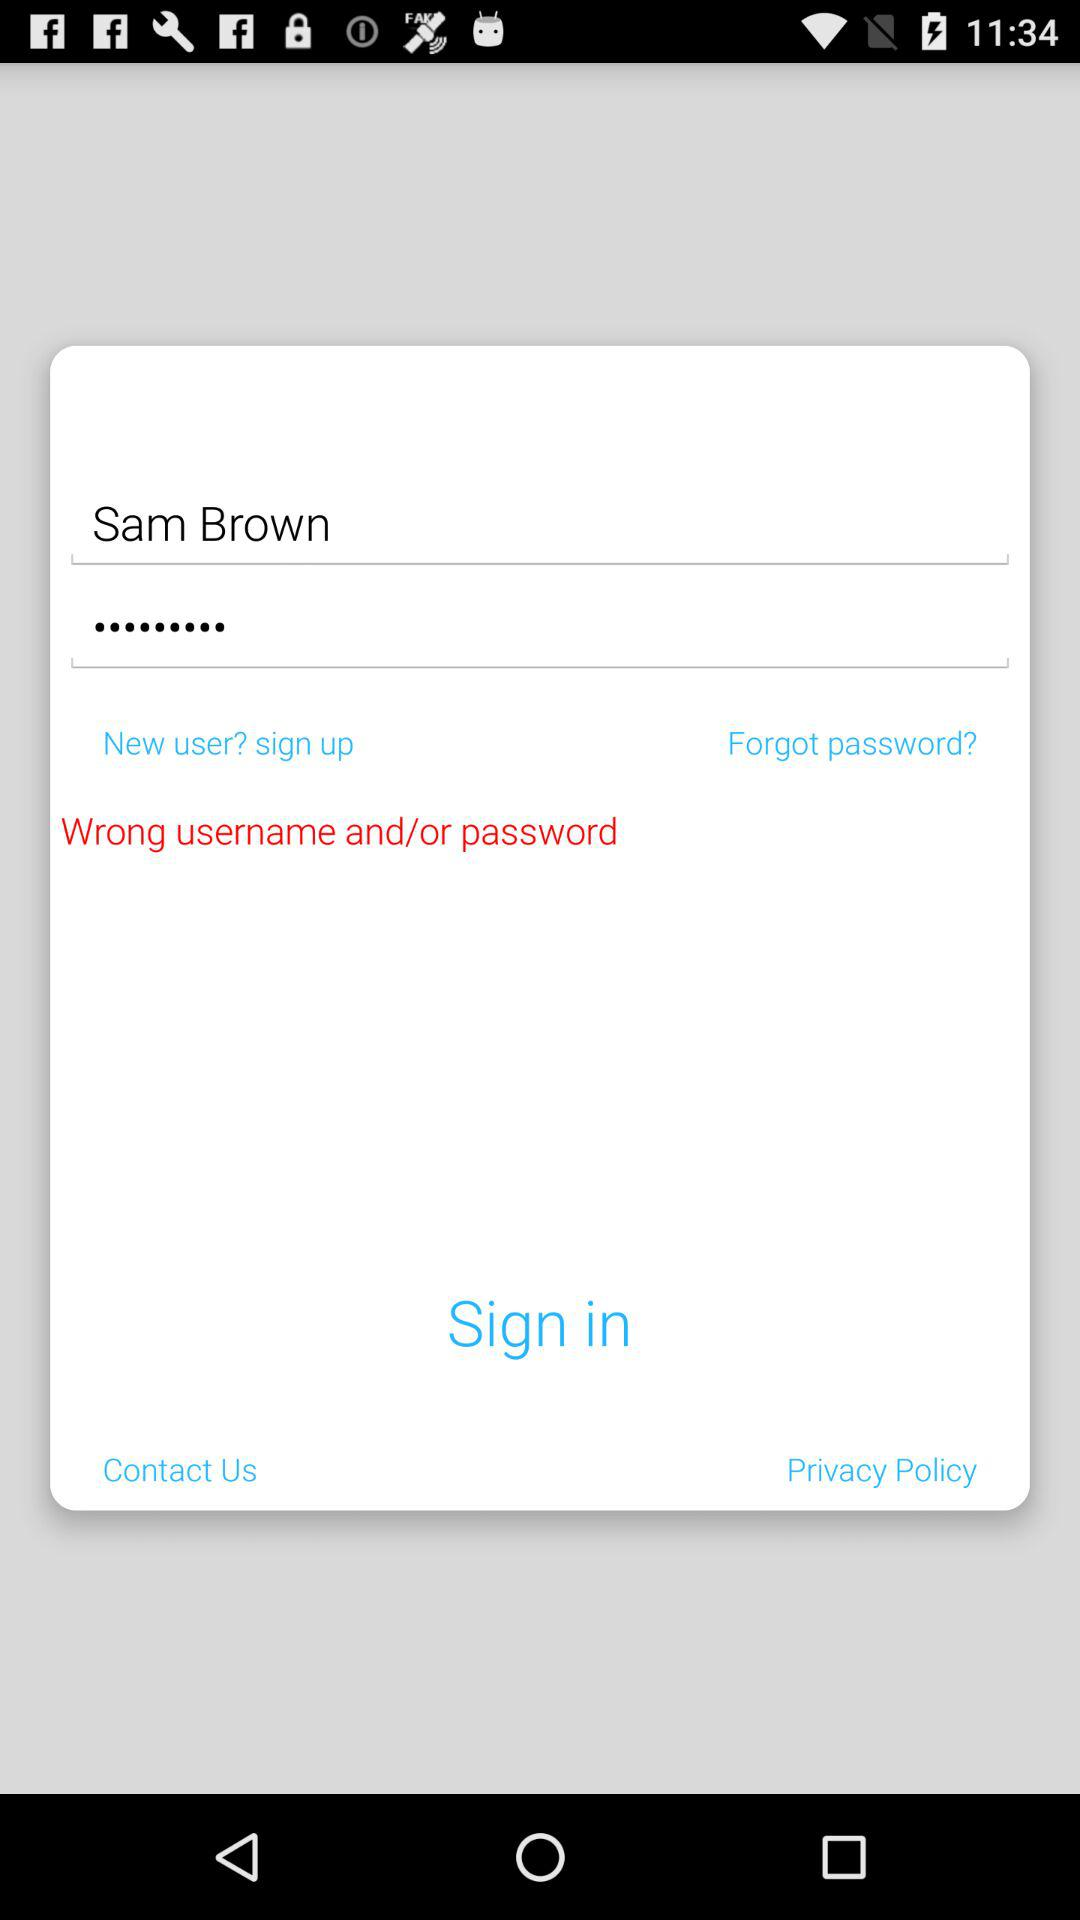What is the name? The name is Sam Brown. 